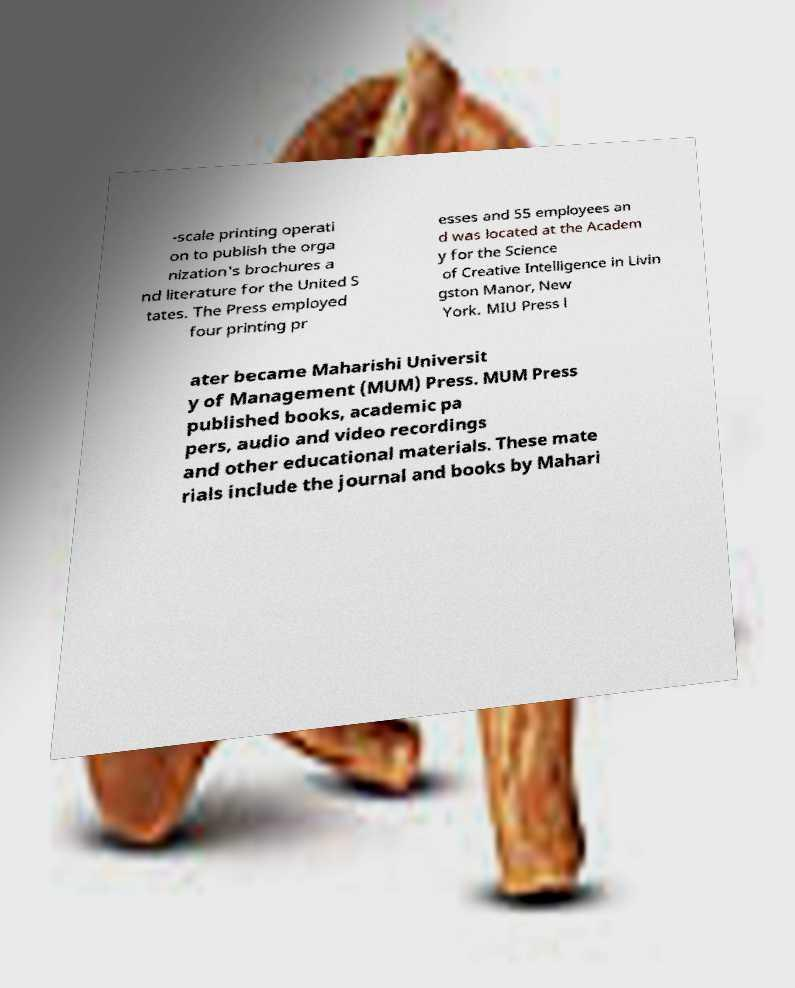Please identify and transcribe the text found in this image. -scale printing operati on to publish the orga nization's brochures a nd literature for the United S tates. The Press employed four printing pr esses and 55 employees an d was located at the Academ y for the Science of Creative Intelligence in Livin gston Manor, New York. MIU Press l ater became Maharishi Universit y of Management (MUM) Press. MUM Press published books, academic pa pers, audio and video recordings and other educational materials. These mate rials include the journal and books by Mahari 